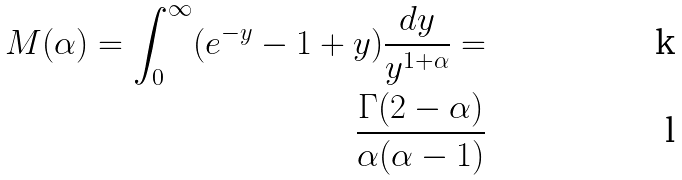Convert formula to latex. <formula><loc_0><loc_0><loc_500><loc_500>M ( \alpha ) = \int _ { 0 } ^ { \infty } ( e ^ { - y } - 1 + y ) \frac { d y } { y ^ { 1 + \alpha } } = \\ \frac { \Gamma ( 2 - \alpha ) } { \alpha ( \alpha - 1 ) }</formula> 